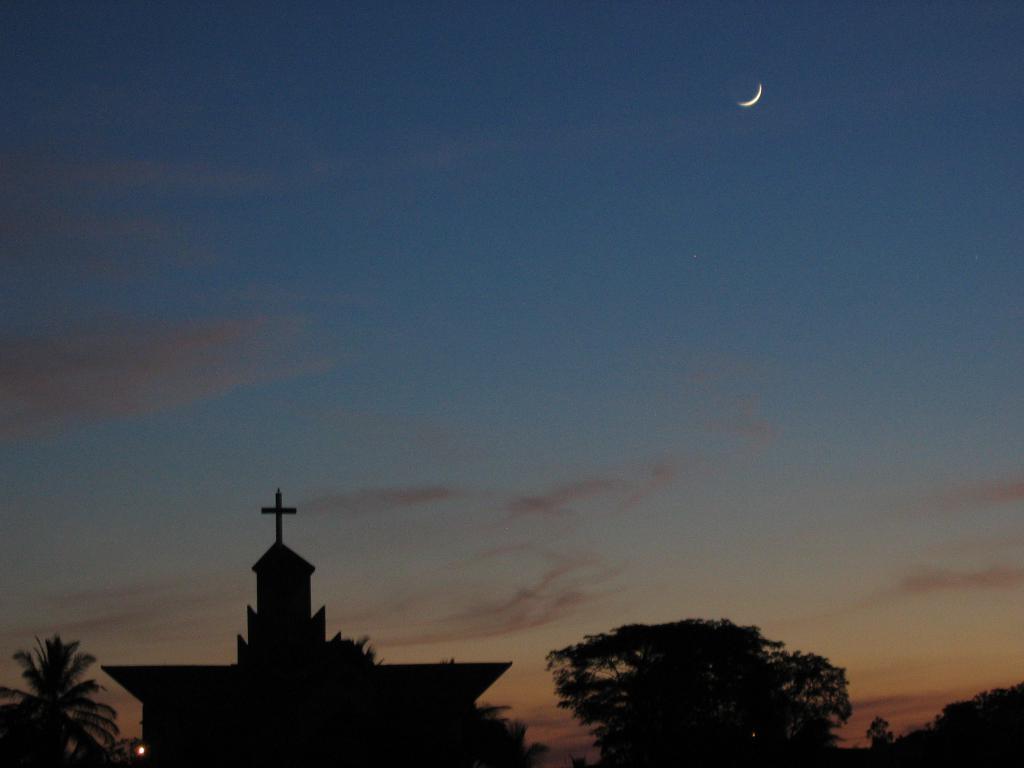Describe this image in one or two sentences. In this picture I can see a house, there are trees, and in the background there is the moon in the sky. 